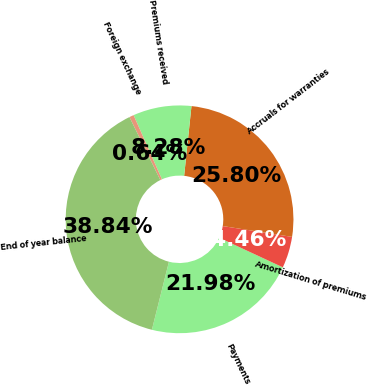Convert chart. <chart><loc_0><loc_0><loc_500><loc_500><pie_chart><fcel>Payments<fcel>Amortization of premiums<fcel>Accruals for warranties<fcel>Premiums received<fcel>Foreign exchange<fcel>End of year balance<nl><fcel>21.98%<fcel>4.46%<fcel>25.8%<fcel>8.28%<fcel>0.64%<fcel>38.84%<nl></chart> 